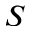Convert formula to latex. <formula><loc_0><loc_0><loc_500><loc_500>S</formula> 